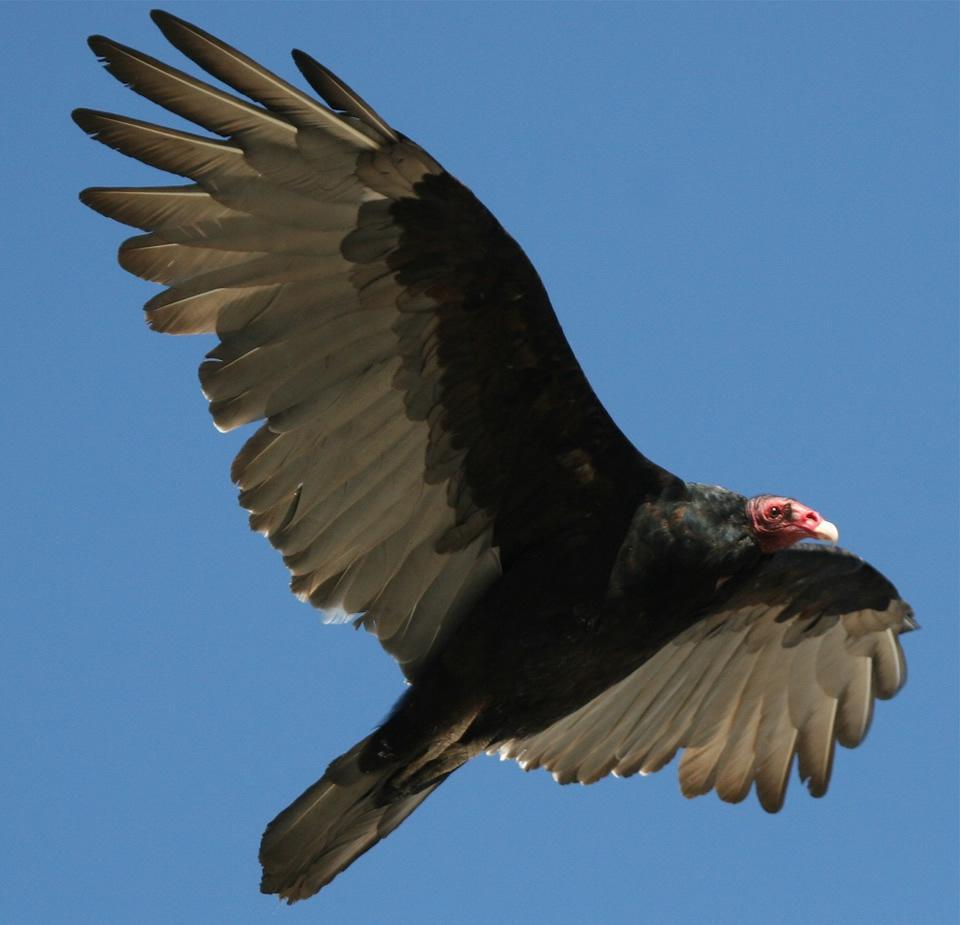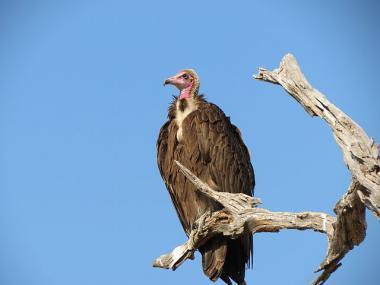The first image is the image on the left, the second image is the image on the right. For the images shown, is this caption "There are three vultures" true? Answer yes or no. No. 